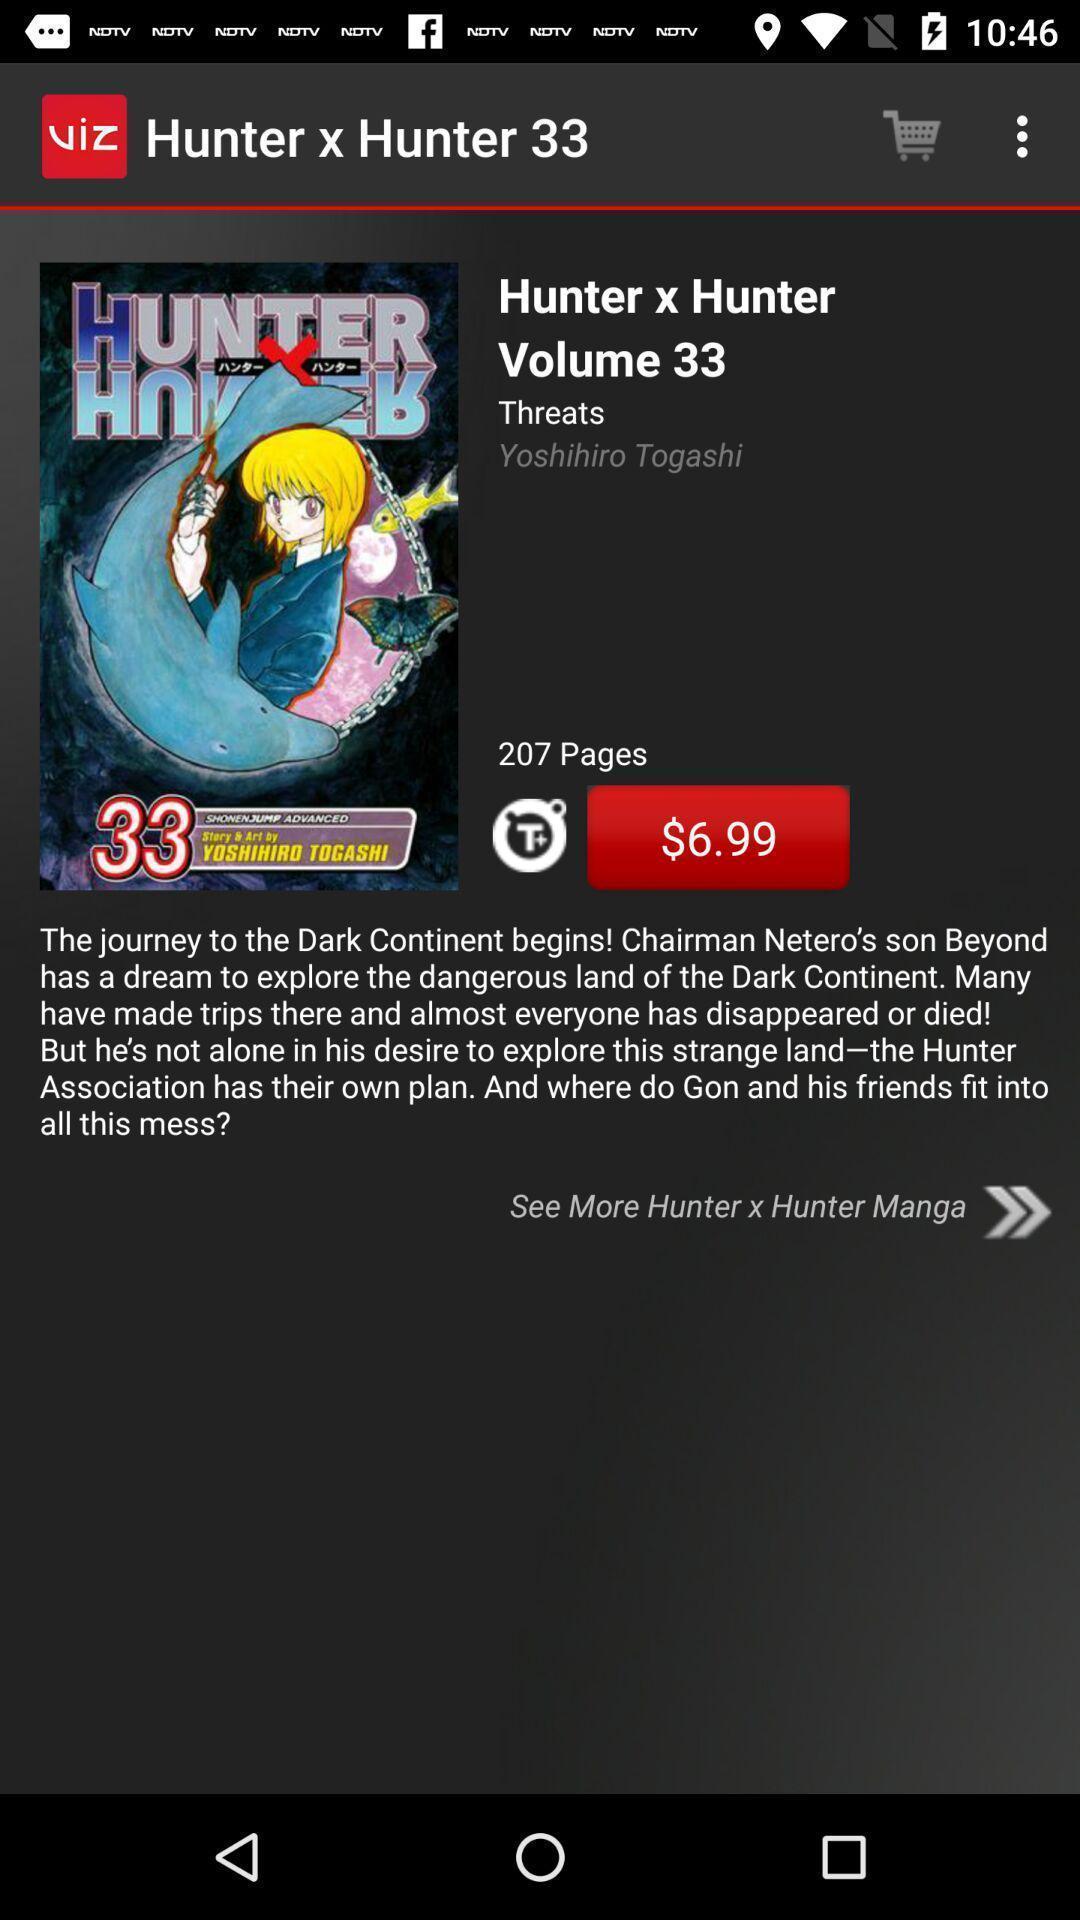Please provide a description for this image. Page displaying the cart. 